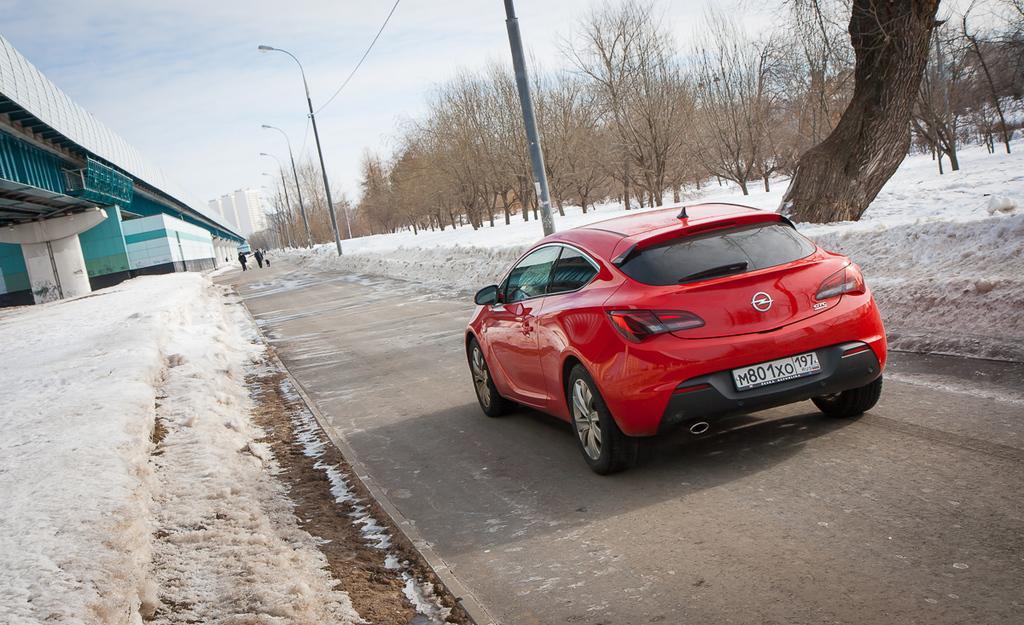In one or two sentences, can you explain what this image depicts? In this image we can see a red color vehicle on the road, there are some poles, lights, trees, buildings, people and snow, in the background we can see the sky and also we can see a bridge. 